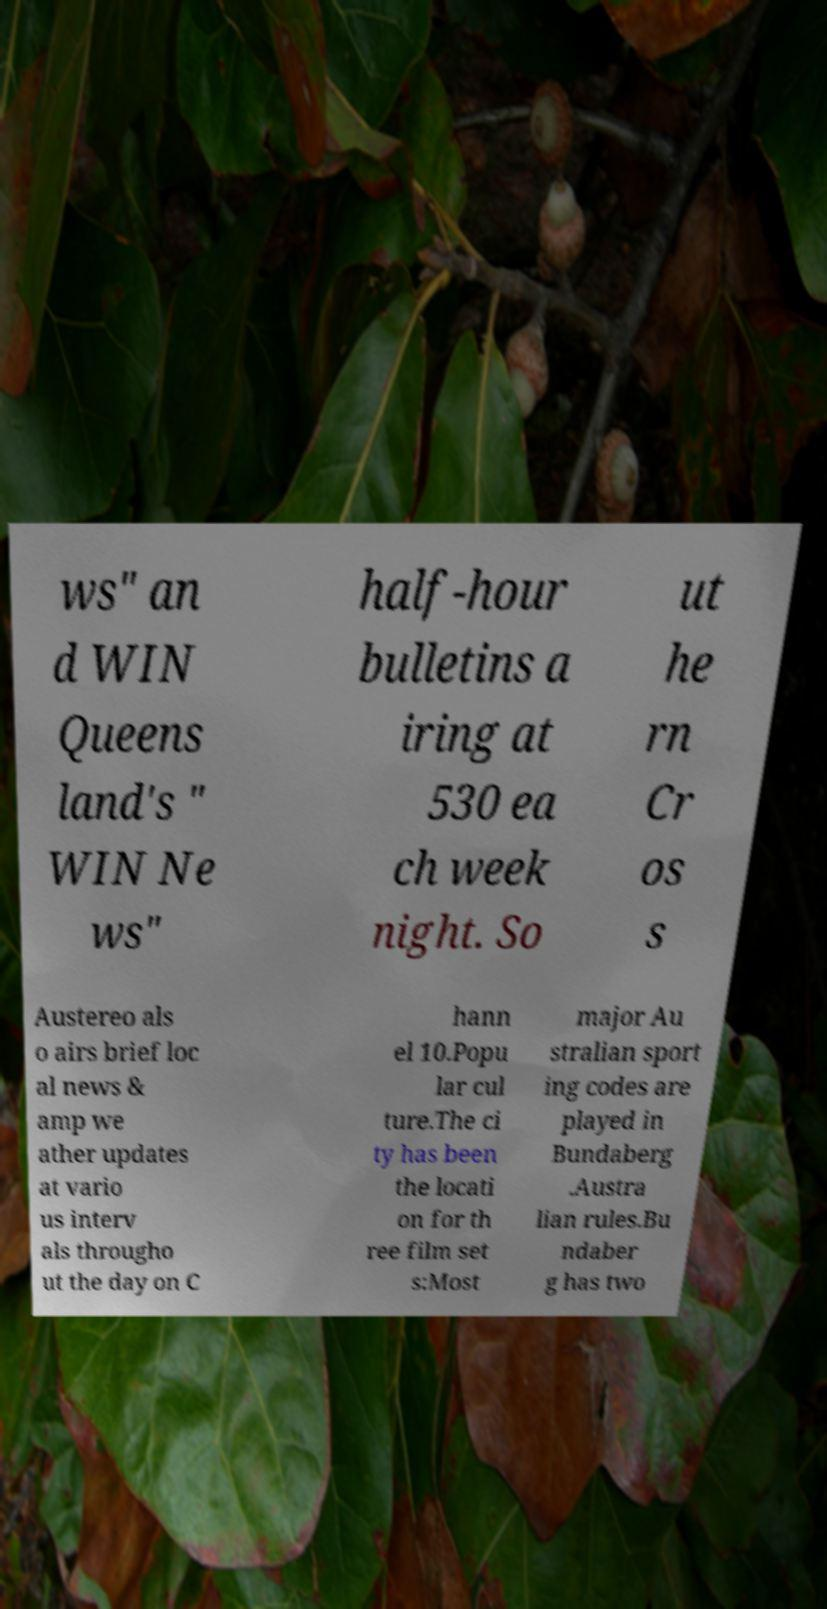I need the written content from this picture converted into text. Can you do that? ws" an d WIN Queens land's " WIN Ne ws" half-hour bulletins a iring at 530 ea ch week night. So ut he rn Cr os s Austereo als o airs brief loc al news & amp we ather updates at vario us interv als througho ut the day on C hann el 10.Popu lar cul ture.The ci ty has been the locati on for th ree film set s:Most major Au stralian sport ing codes are played in Bundaberg .Austra lian rules.Bu ndaber g has two 